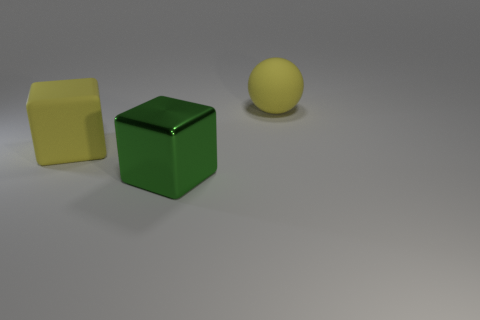What is the object that is both behind the large green thing and to the left of the large rubber sphere made of?
Keep it short and to the point. Rubber. There is a yellow thing that is the same size as the ball; what material is it?
Make the answer very short. Rubber. There is another yellow thing that is the same shape as the shiny object; what is its material?
Make the answer very short. Rubber. Is there anything else that is made of the same material as the green cube?
Your response must be concise. No. How many cylinders are either big metallic objects or big yellow matte objects?
Provide a succinct answer. 0. There is a yellow rubber object right of the green shiny thing; is it the same size as the matte thing that is left of the green metal block?
Make the answer very short. Yes. What is the large yellow thing behind the big yellow object that is in front of the large yellow rubber sphere made of?
Make the answer very short. Rubber. Are there fewer shiny blocks on the left side of the large green object than rubber things?
Offer a very short reply. Yes. There is a thing that is the same material as the large yellow sphere; what shape is it?
Provide a short and direct response. Cube. What number of other objects are there of the same shape as the metal object?
Keep it short and to the point. 1. 